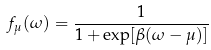Convert formula to latex. <formula><loc_0><loc_0><loc_500><loc_500>f _ { \mu } ( \omega ) = \frac { 1 } { 1 + \exp [ \beta ( \omega - \mu ) ] }</formula> 